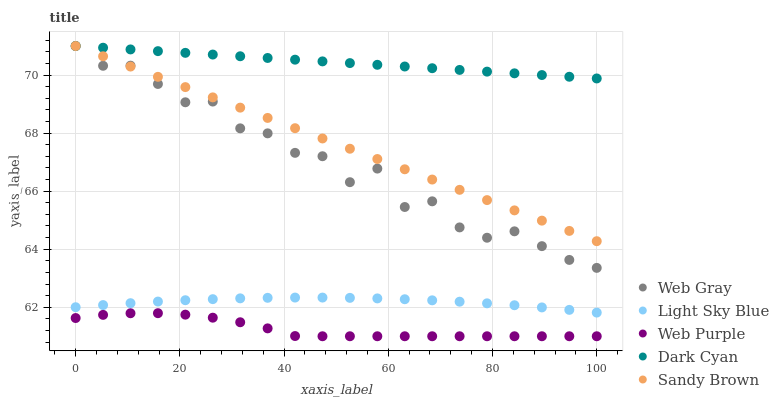Does Web Purple have the minimum area under the curve?
Answer yes or no. Yes. Does Dark Cyan have the maximum area under the curve?
Answer yes or no. Yes. Does Web Gray have the minimum area under the curve?
Answer yes or no. No. Does Web Gray have the maximum area under the curve?
Answer yes or no. No. Is Sandy Brown the smoothest?
Answer yes or no. Yes. Is Web Gray the roughest?
Answer yes or no. Yes. Is Web Purple the smoothest?
Answer yes or no. No. Is Web Purple the roughest?
Answer yes or no. No. Does Web Purple have the lowest value?
Answer yes or no. Yes. Does Web Gray have the lowest value?
Answer yes or no. No. Does Sandy Brown have the highest value?
Answer yes or no. Yes. Does Web Purple have the highest value?
Answer yes or no. No. Is Web Purple less than Web Gray?
Answer yes or no. Yes. Is Dark Cyan greater than Light Sky Blue?
Answer yes or no. Yes. Does Dark Cyan intersect Web Gray?
Answer yes or no. Yes. Is Dark Cyan less than Web Gray?
Answer yes or no. No. Is Dark Cyan greater than Web Gray?
Answer yes or no. No. Does Web Purple intersect Web Gray?
Answer yes or no. No. 